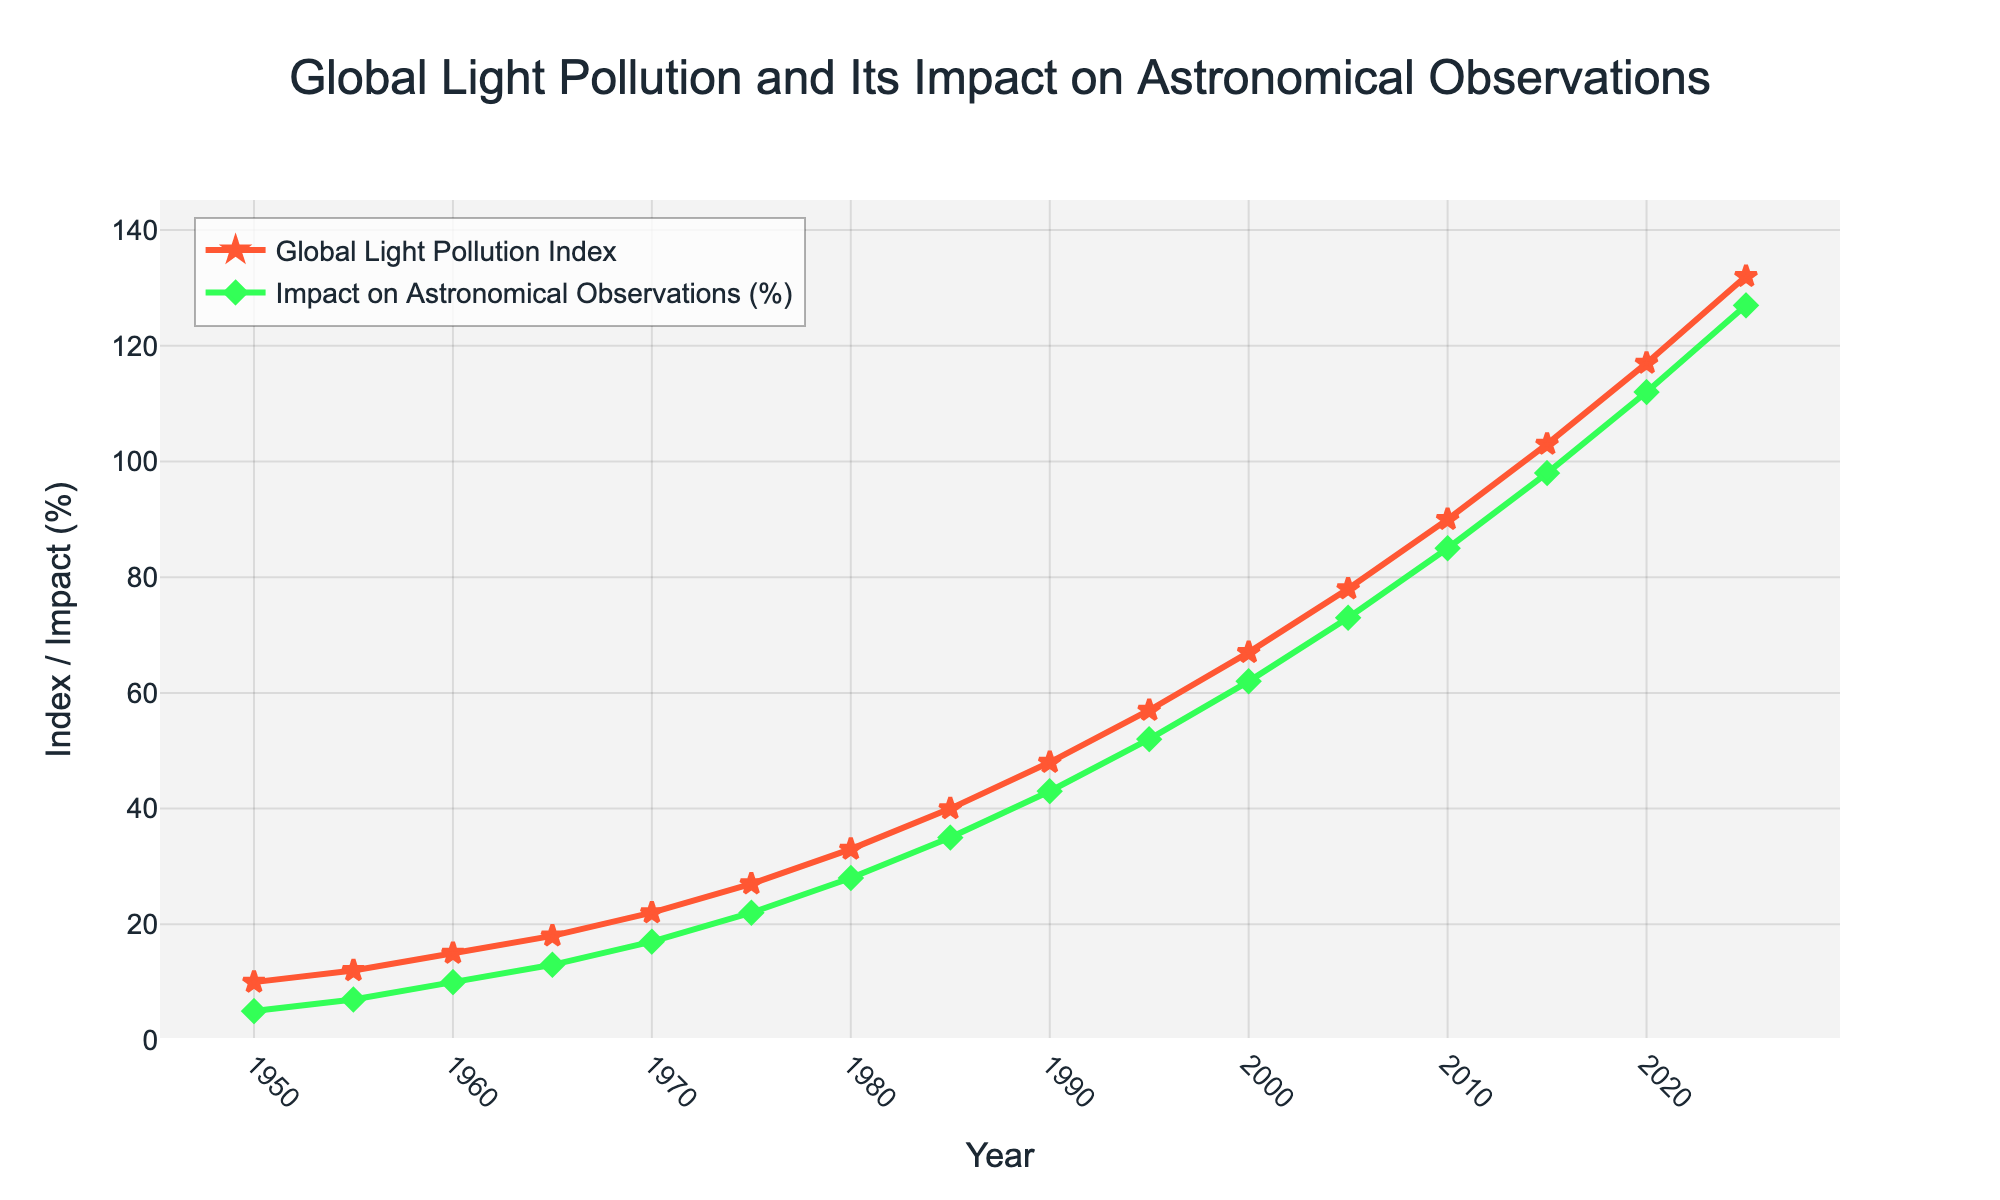What trends do you see in the Global Light Pollution Index over the years? The Global Light Pollution Index has been increasing consistently from 1950 to 2025, indicating a growing amount of light pollution globally. This is visually represented by the upward sloping red line on the chart.
Answer: Increasing How much did the Impact on Astronomical Observations (%) increase between 1950 and 2025? The Impact on Astronomical Observations (%) in 1950 was 5% and in 2025 it was 127%. The increase can be calculated as 127% - 5% = 122%.
Answer: 122% Which year showed the highest Global Light Pollution Index and what was the value? The highest Global Light Pollution Index was in the year 2025, with a value of 132. This is visible as the peak of the red line in the graph.
Answer: 2025, 132 In which decade did the Global Light Pollution Index see the most significant increase? By examining the chart, the increase in the Global Light Pollution Index appears to be most significant between the 2000s and 2010s. In 2000, the index was 67, and by 2010 it was 90, a difference of 23.
Answer: 2000s-2010s How does the growth trend of the Impact on Astronomical Observations (%) compare to that of the Global Light Pollution Index from 1950 to 2025? Both trends show an increasing pattern, but the Impact on Astronomical Observations (%) appears to rise at a slightly higher rate in recent years compared to the Global Light Pollution Index. This is indicated by the steeper slope of the green line in the latter part of the graph.
Answer: Impact on Astronomical Observations rises faster What is the approximate average value of the Global Light Pollution Index from 1950 to 2025? Sum the values of the Global Light Pollution Index (10, 12, 15, 18, 22, 27, 33, 40, 48, 57, 67, 78, 90, 103, 117, 132) to get 769. There are 16 data points, so the average is 769 / 16 which equals approximately 48.06.
Answer: 48.06 Is the Impact on Astronomical Observations (%) ever lower than the Global Light Pollution Index? If so, during which years does this occur? A comparison of the two lines shows that the Impact on Astronomical Observations (%) is lower than the Global Light Pollution Index for every year from 1950 to 2025. This is identifiable as the green line is always below the red line.
Answer: Every year How much did both the Global Light Pollution Index and the Impact on Astronomical Observations (%) increase from 2000 to 2015? In 2000, the Global Light Pollution Index was 67, and in 2015 it was 103, an increase of 36. The Impact on Astronomical Observations (%) was 62% in 2000 and 98% in 2015, an increase of 36%.
Answer: Both increased by 36 What is the visual difference between the markers used for the Global Light Pollution Index and the Impact on Astronomical Observations (%)? The markers for the Global Light Pollution Index are star-shaped and red, while the markers for the Impact on Astronomical Observations (%) are diamond-shaped and green. This distinction can be easily seen in the chart's legend.
Answer: Star-shaped red vs. Diamond-shaped green Between which consecutive years did the Impact on Astronomical Observations (%) see the largest single increase? By examining the green markers, the largest single increase appears to be between 2005 and 2010. The values changed from 73% in 2005 to 85% in 2010, an increase of 12%.
Answer: 2005-2010 